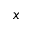<formula> <loc_0><loc_0><loc_500><loc_500>x</formula> 